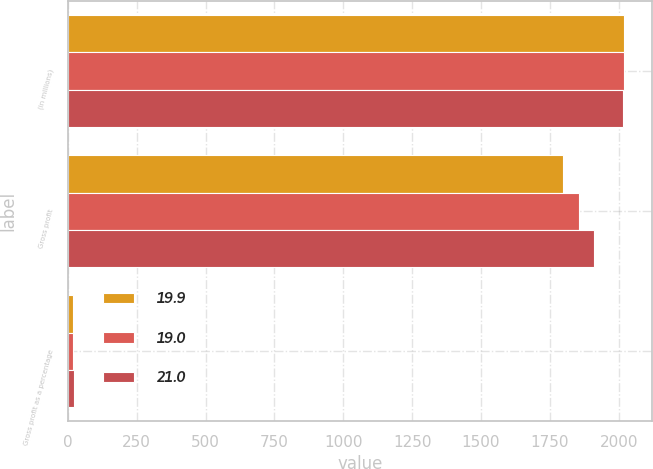<chart> <loc_0><loc_0><loc_500><loc_500><stacked_bar_chart><ecel><fcel>(in millions)<fcel>Gross profit<fcel>Gross profit as a percentage<nl><fcel>19.9<fcel>2019<fcel>1799.1<fcel>19<nl><fcel>19<fcel>2018<fcel>1856.8<fcel>19.9<nl><fcel>21<fcel>2017<fcel>1911.8<fcel>21<nl></chart> 